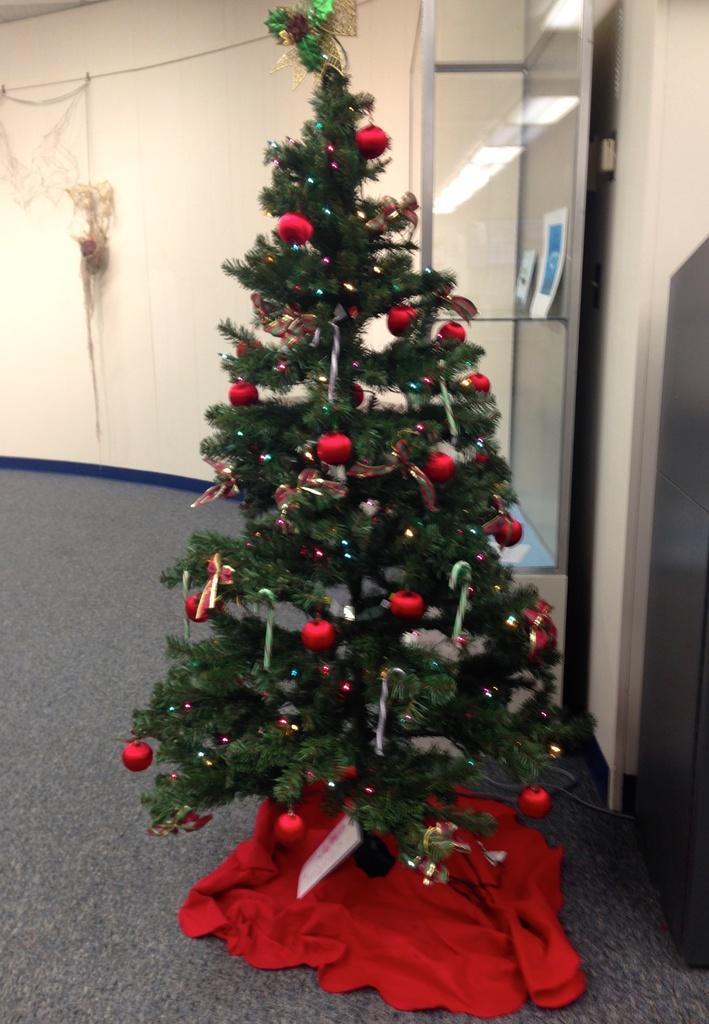Describe this image in one or two sentences. In this picture I can see a tree decorated with lights, balls and some other items, there is carpet, there are two items in a glass box, and in the background this is looking a net on the wall. 